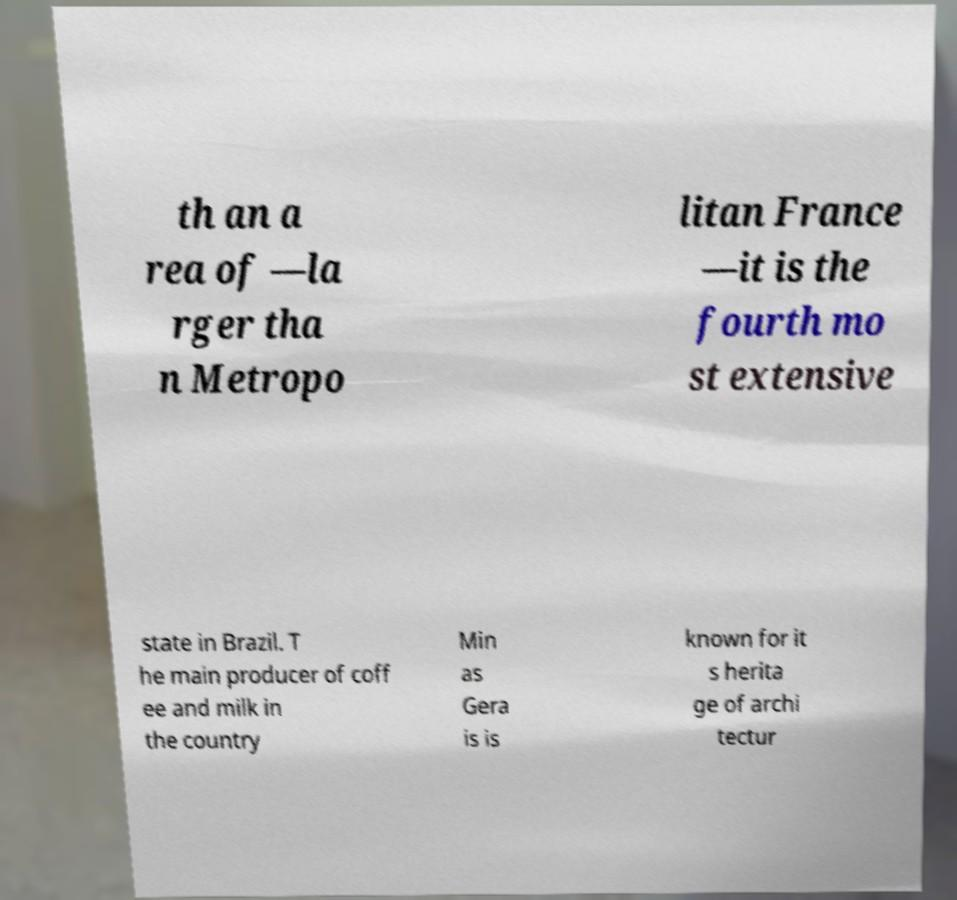Could you assist in decoding the text presented in this image and type it out clearly? th an a rea of —la rger tha n Metropo litan France —it is the fourth mo st extensive state in Brazil. T he main producer of coff ee and milk in the country Min as Gera is is known for it s herita ge of archi tectur 